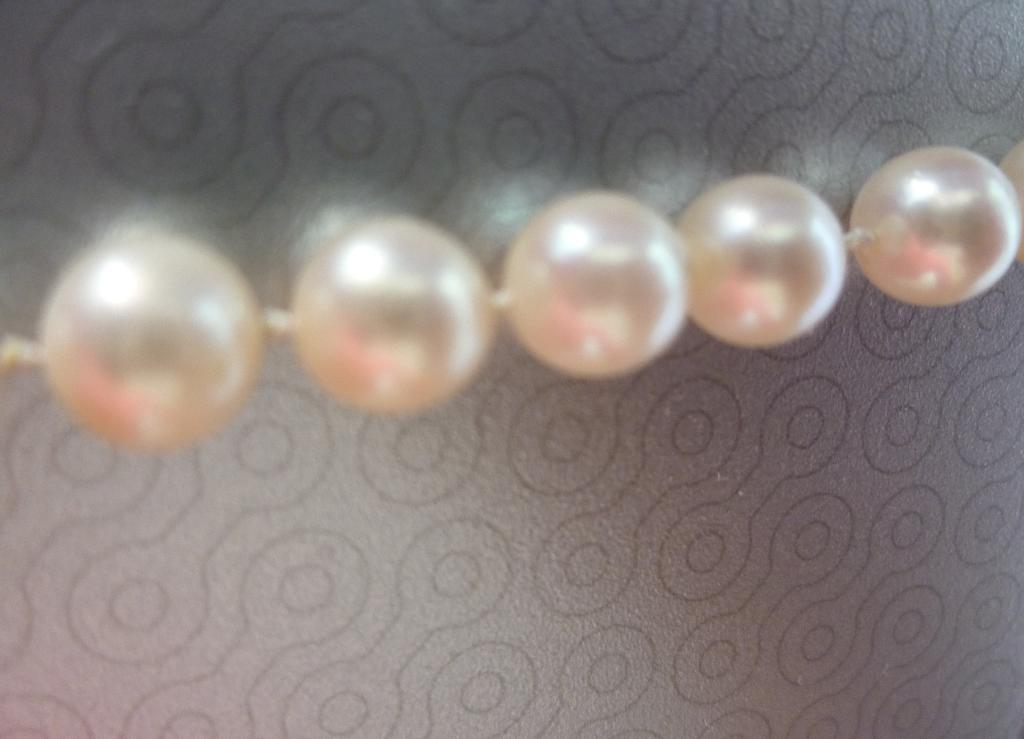How many beads can be seen in the front of the image? There are five beads in the front of the image. What color is the background of the image? The background of the image is grey. What can be observed on the grey background? There are designs visible on the grey background. What type of bag is being used to hold the beads in the image? There is no bag present in the image; the beads are simply placed in the front. 